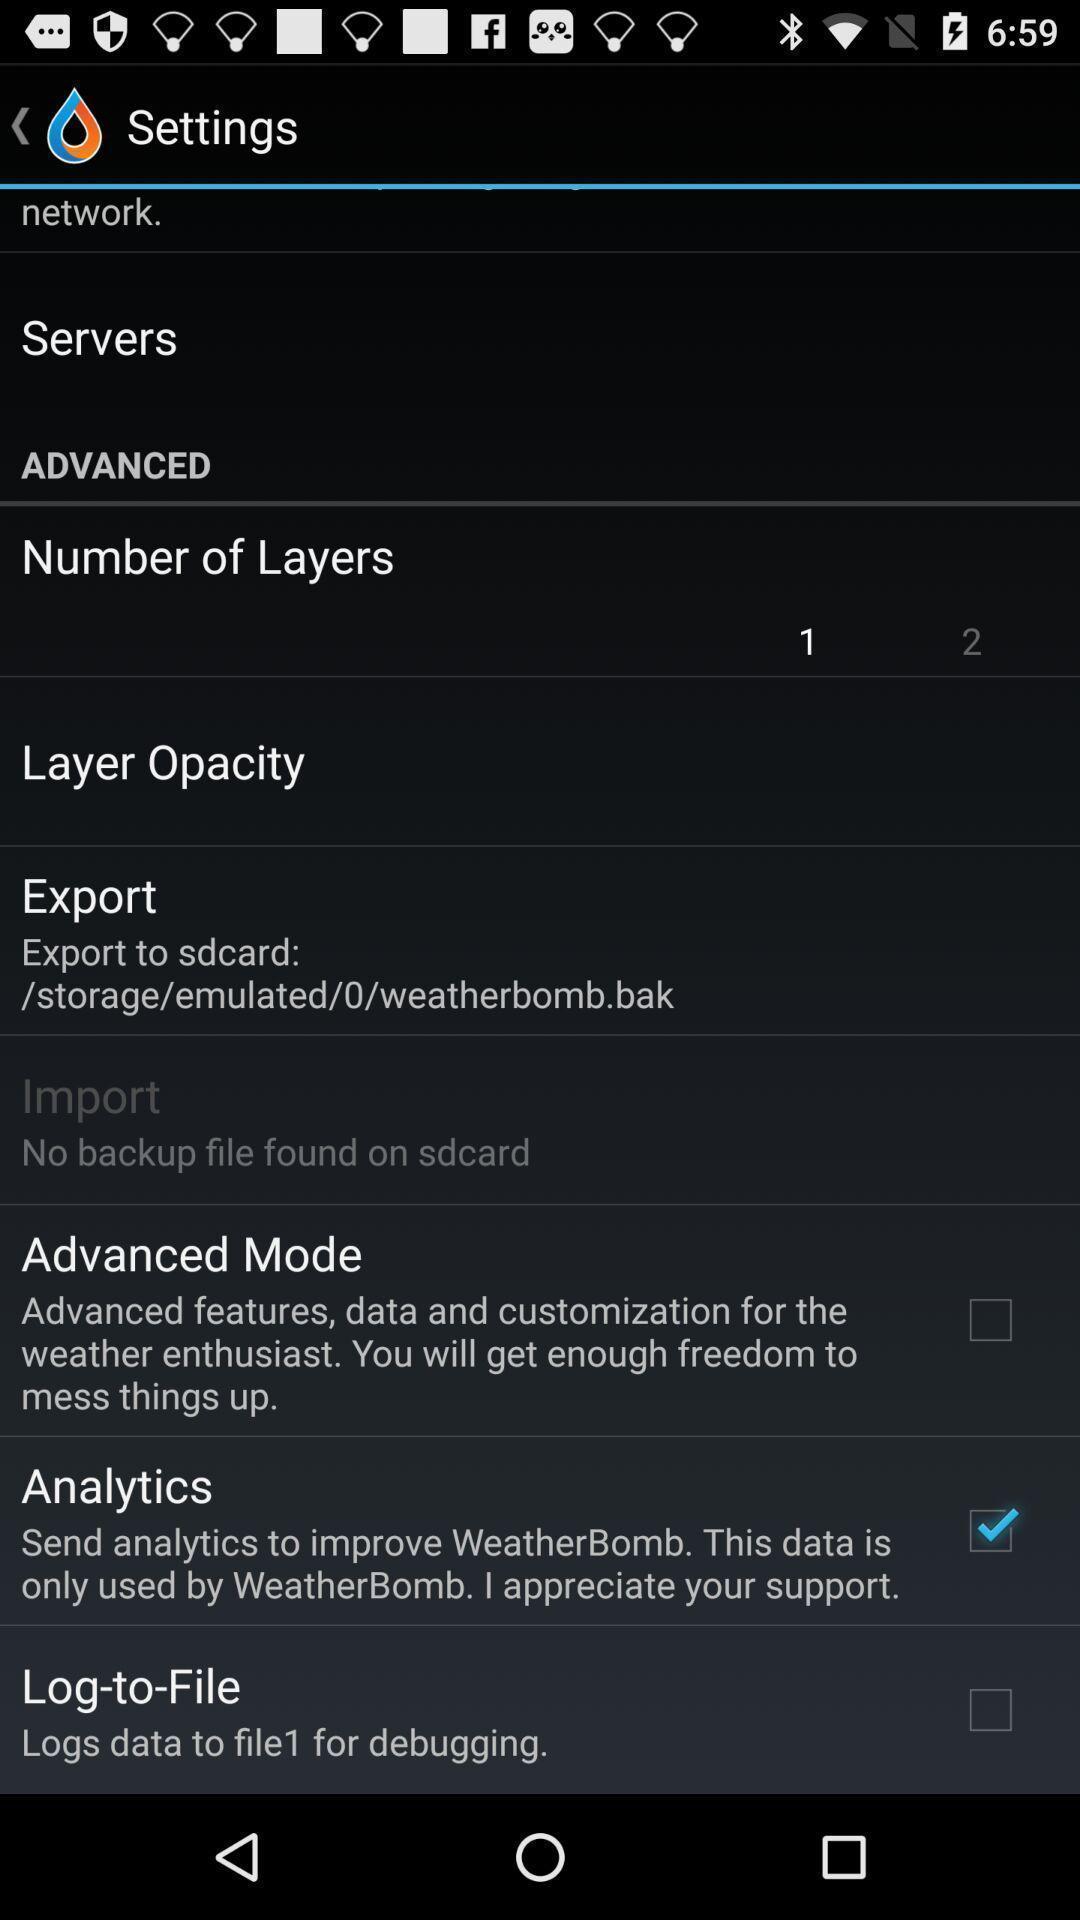Provide a description of this screenshot. Settings page. 